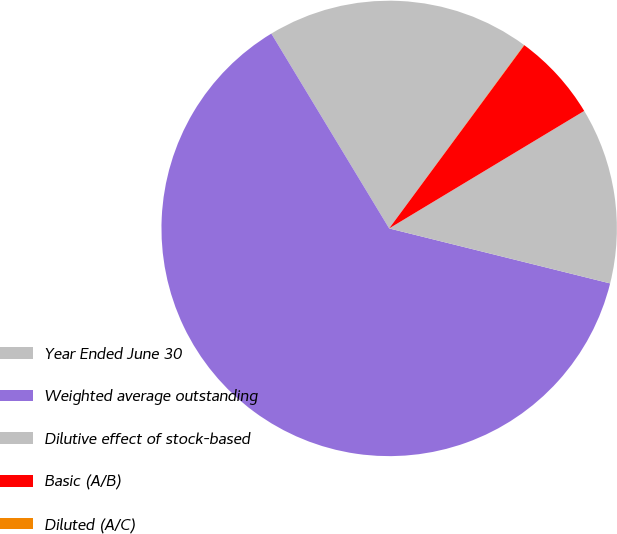<chart> <loc_0><loc_0><loc_500><loc_500><pie_chart><fcel>Year Ended June 30<fcel>Weighted average outstanding<fcel>Dilutive effect of stock-based<fcel>Basic (A/B)<fcel>Diluted (A/C)<nl><fcel>18.75%<fcel>62.46%<fcel>12.51%<fcel>6.26%<fcel>0.02%<nl></chart> 